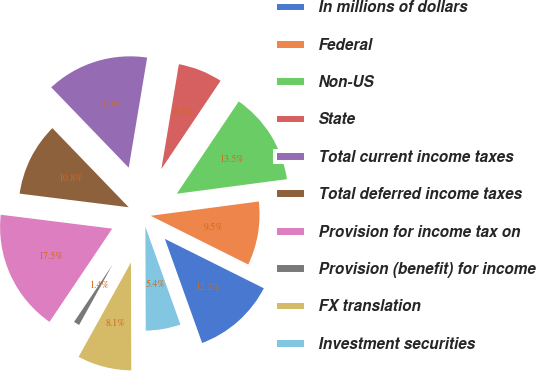<chart> <loc_0><loc_0><loc_500><loc_500><pie_chart><fcel>In millions of dollars<fcel>Federal<fcel>Non-US<fcel>State<fcel>Total current income taxes<fcel>Total deferred income taxes<fcel>Provision for income tax on<fcel>Provision (benefit) for income<fcel>FX translation<fcel>Investment securities<nl><fcel>12.16%<fcel>9.46%<fcel>13.5%<fcel>6.77%<fcel>14.85%<fcel>10.81%<fcel>17.55%<fcel>1.37%<fcel>8.11%<fcel>5.42%<nl></chart> 